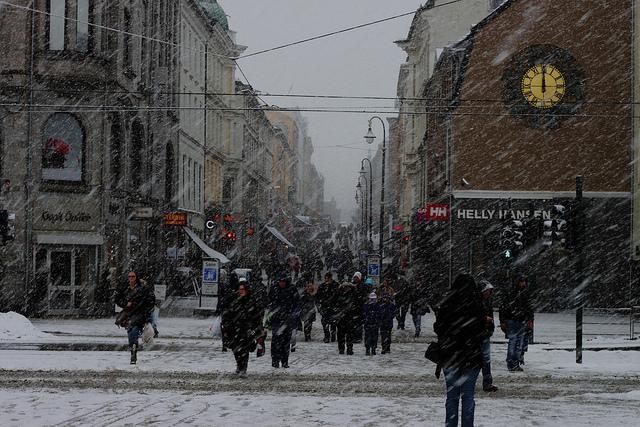What kind of weather is present in the scene?
Be succinct. Snowy. What is the time in the scene?
Answer briefly. 12:00. Are they families?
Concise answer only. No. Are this policemen?
Short answer required. No. What is the man doing?
Write a very short answer. Walking. Is it daytime?
Answer briefly. Yes. What type of weather is occurring?
Give a very brief answer. Snow. What is the name of the building in the background?
Answer briefly. Helly hansen. 